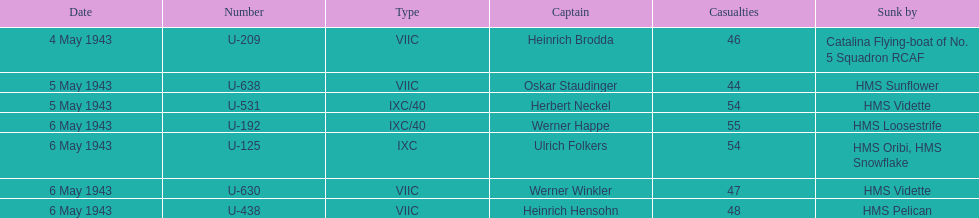What was the first u-boat to accomplish a sinking? U-209. 